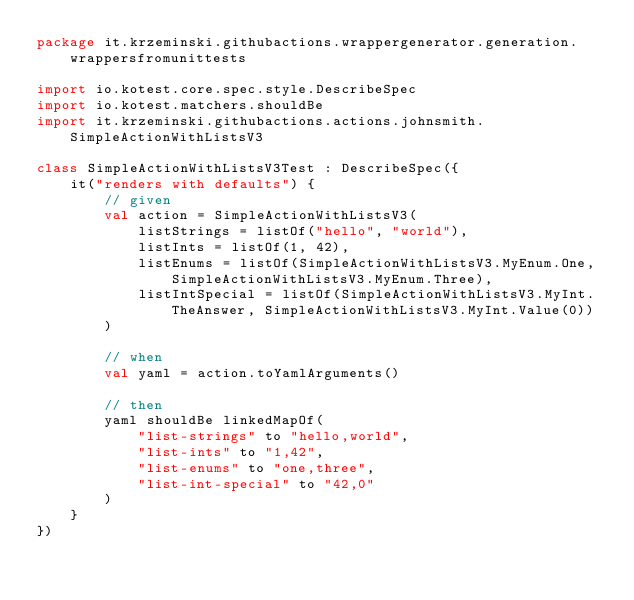Convert code to text. <code><loc_0><loc_0><loc_500><loc_500><_Kotlin_>package it.krzeminski.githubactions.wrappergenerator.generation.wrappersfromunittests

import io.kotest.core.spec.style.DescribeSpec
import io.kotest.matchers.shouldBe
import it.krzeminski.githubactions.actions.johnsmith.SimpleActionWithListsV3

class SimpleActionWithListsV3Test : DescribeSpec({
    it("renders with defaults") {
        // given
        val action = SimpleActionWithListsV3(
            listStrings = listOf("hello", "world"),
            listInts = listOf(1, 42),
            listEnums = listOf(SimpleActionWithListsV3.MyEnum.One, SimpleActionWithListsV3.MyEnum.Three),
            listIntSpecial = listOf(SimpleActionWithListsV3.MyInt.TheAnswer, SimpleActionWithListsV3.MyInt.Value(0))
        )

        // when
        val yaml = action.toYamlArguments()

        // then
        yaml shouldBe linkedMapOf(
            "list-strings" to "hello,world",
            "list-ints" to "1,42",
            "list-enums" to "one,three",
            "list-int-special" to "42,0"
        )
    }
})
</code> 